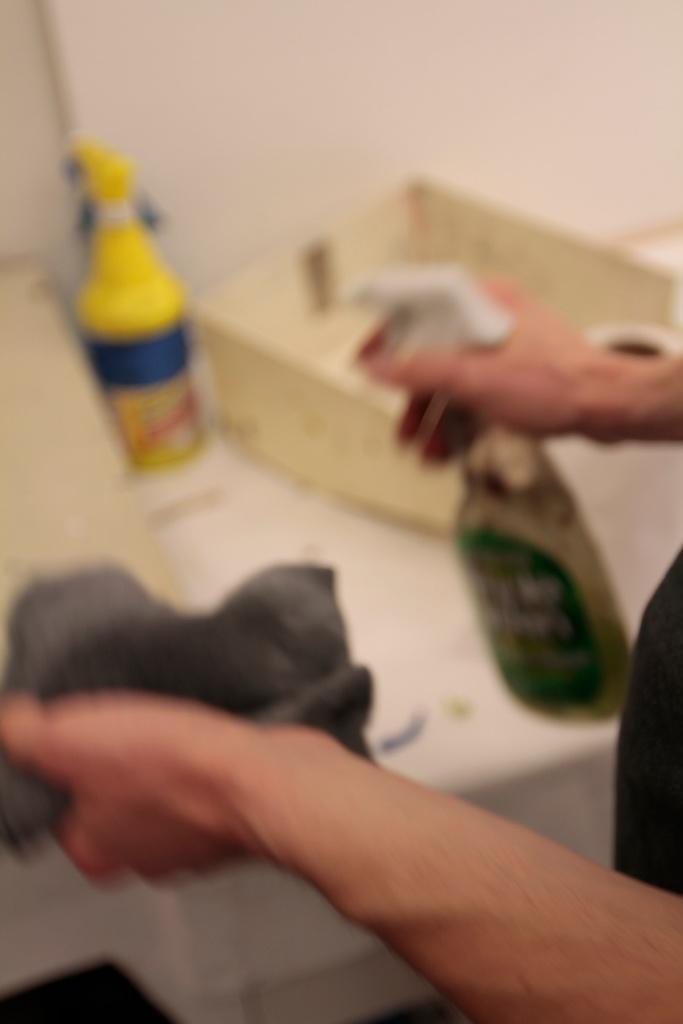Who or what is present in the image? There is a person in the image. What is the person holding in their hands? The person is holding a bottle. Where is the bottle located in relation to the person? The bottle is in the person's hands. What other object can be seen in the image? There is a box in the image. What is the background of the image? There is a wall in the image. How many family members are visible in the image? There is no family member visible in the image, only a person holding a bottle. Can you see a bee buzzing around the person in the image? There is no bee present in the image. 